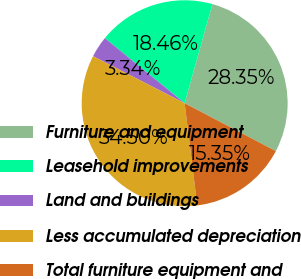Convert chart to OTSL. <chart><loc_0><loc_0><loc_500><loc_500><pie_chart><fcel>Furniture and equipment<fcel>Leasehold improvements<fcel>Land and buildings<fcel>Less accumulated depreciation<fcel>Total furniture equipment and<nl><fcel>28.35%<fcel>18.46%<fcel>3.34%<fcel>34.5%<fcel>15.35%<nl></chart> 